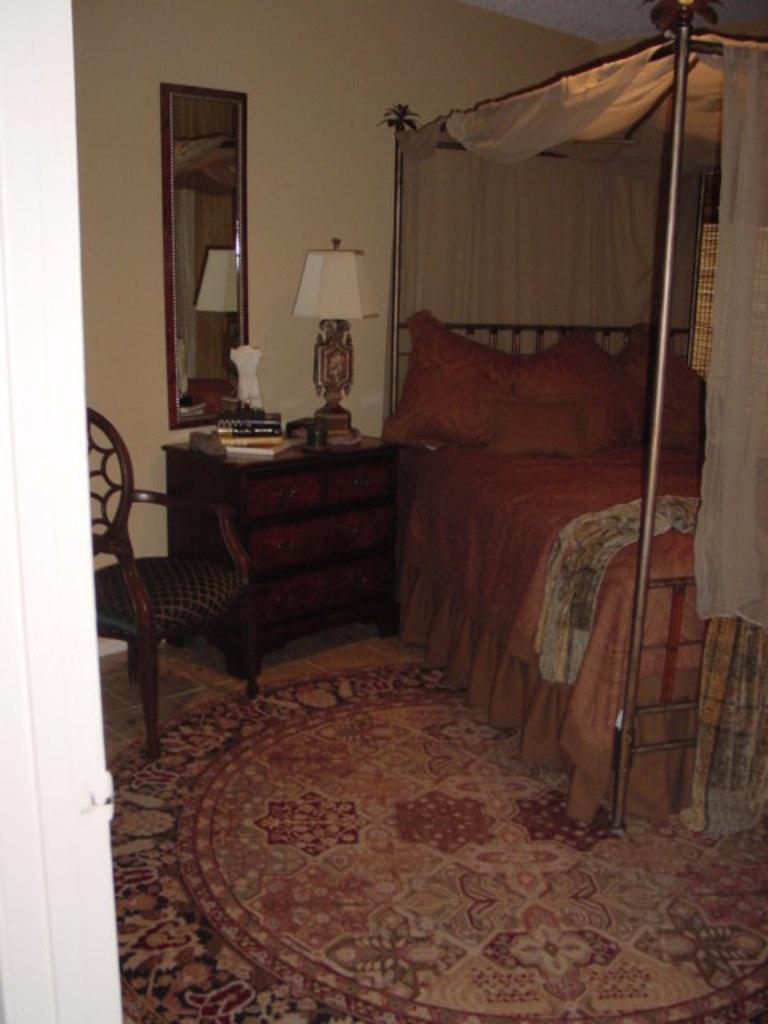What type of furniture is present in the image? There is a chair, a mirror, a lamp, and a bed in the image. Can you describe the purpose of each item? The chair is likely for sitting, the mirror is for reflection, the lamp provides light, and the bed is for sleeping or resting. What might be the function of the mirror in the image? The mirror could be used for personal grooming, checking one's appearance, or creating the illusion of a larger space. What type of soup is being served in the bowl on the bed? There is no bowl or soup present in the image; it only features a chair, a mirror, a lamp, and a bed. 